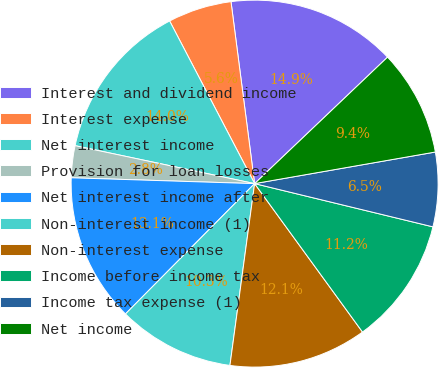Convert chart. <chart><loc_0><loc_0><loc_500><loc_500><pie_chart><fcel>Interest and dividend income<fcel>Interest expense<fcel>Net interest income<fcel>Provision for loan losses<fcel>Net interest income after<fcel>Non-interest income (1)<fcel>Non-interest expense<fcel>Income before income tax<fcel>Income tax expense (1)<fcel>Net income<nl><fcel>14.95%<fcel>5.61%<fcel>14.02%<fcel>2.81%<fcel>13.08%<fcel>10.28%<fcel>12.15%<fcel>11.21%<fcel>6.54%<fcel>9.35%<nl></chart> 